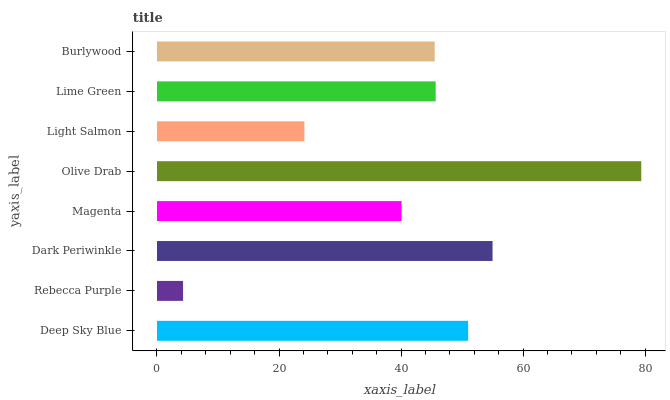Is Rebecca Purple the minimum?
Answer yes or no. Yes. Is Olive Drab the maximum?
Answer yes or no. Yes. Is Dark Periwinkle the minimum?
Answer yes or no. No. Is Dark Periwinkle the maximum?
Answer yes or no. No. Is Dark Periwinkle greater than Rebecca Purple?
Answer yes or no. Yes. Is Rebecca Purple less than Dark Periwinkle?
Answer yes or no. Yes. Is Rebecca Purple greater than Dark Periwinkle?
Answer yes or no. No. Is Dark Periwinkle less than Rebecca Purple?
Answer yes or no. No. Is Lime Green the high median?
Answer yes or no. Yes. Is Burlywood the low median?
Answer yes or no. Yes. Is Light Salmon the high median?
Answer yes or no. No. Is Rebecca Purple the low median?
Answer yes or no. No. 